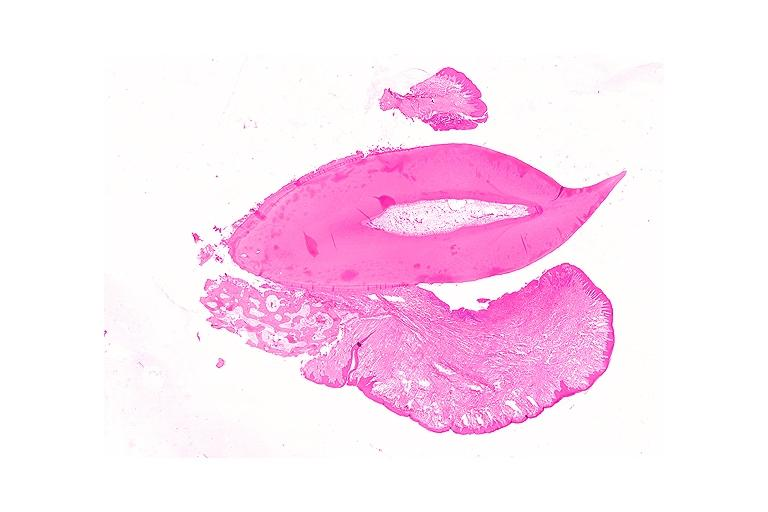what is present?
Answer the question using a single word or phrase. Oral 